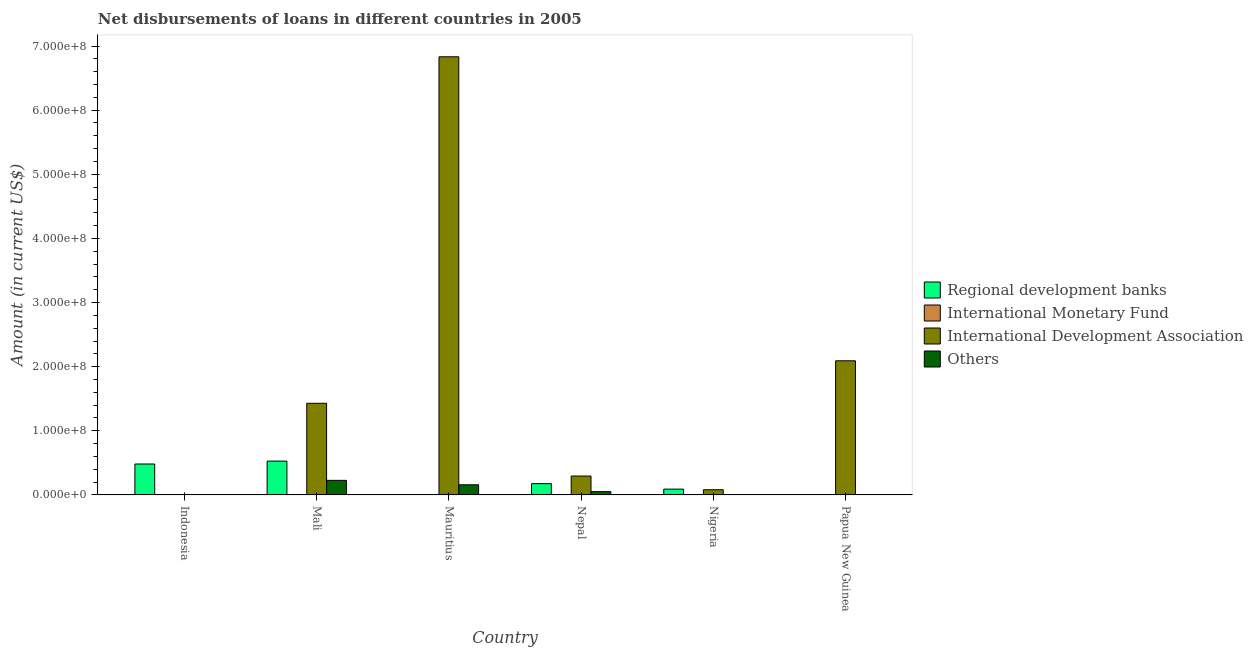What is the label of the 3rd group of bars from the left?
Provide a short and direct response. Mauritius. What is the amount of loan disimbursed by regional development banks in Mauritius?
Your answer should be very brief. 0. Across all countries, what is the maximum amount of loan disimbursed by international development association?
Offer a terse response. 6.83e+08. Across all countries, what is the minimum amount of loan disimbursed by international monetary fund?
Provide a short and direct response. 0. In which country was the amount of loan disimbursed by international development association maximum?
Provide a short and direct response. Mauritius. What is the difference between the amount of loan disimbursed by regional development banks in Indonesia and that in Nigeria?
Offer a terse response. 3.92e+07. What is the difference between the amount of loan disimbursed by other organisations in Mali and the amount of loan disimbursed by international monetary fund in Papua New Guinea?
Your answer should be very brief. 2.27e+07. What is the average amount of loan disimbursed by international development association per country?
Keep it short and to the point. 1.79e+08. What is the difference between the amount of loan disimbursed by other organisations and amount of loan disimbursed by international development association in Mauritius?
Keep it short and to the point. -6.67e+08. What is the ratio of the amount of loan disimbursed by other organisations in Mali to that in Mauritius?
Provide a short and direct response. 1.44. What is the difference between the highest and the second highest amount of loan disimbursed by other organisations?
Your answer should be compact. 6.90e+06. What is the difference between the highest and the lowest amount of loan disimbursed by other organisations?
Your answer should be very brief. 2.27e+07. Are all the bars in the graph horizontal?
Give a very brief answer. No. What is the difference between two consecutive major ticks on the Y-axis?
Give a very brief answer. 1.00e+08. Are the values on the major ticks of Y-axis written in scientific E-notation?
Provide a short and direct response. Yes. Does the graph contain grids?
Give a very brief answer. No. What is the title of the graph?
Provide a succinct answer. Net disbursements of loans in different countries in 2005. What is the label or title of the Y-axis?
Provide a short and direct response. Amount (in current US$). What is the Amount (in current US$) in Regional development banks in Indonesia?
Your answer should be compact. 4.82e+07. What is the Amount (in current US$) of International Development Association in Indonesia?
Your response must be concise. 0. What is the Amount (in current US$) in Regional development banks in Mali?
Make the answer very short. 5.28e+07. What is the Amount (in current US$) of International Monetary Fund in Mali?
Offer a terse response. 0. What is the Amount (in current US$) of International Development Association in Mali?
Offer a very short reply. 1.43e+08. What is the Amount (in current US$) in Others in Mali?
Offer a terse response. 2.27e+07. What is the Amount (in current US$) in Regional development banks in Mauritius?
Give a very brief answer. 0. What is the Amount (in current US$) in International Monetary Fund in Mauritius?
Your answer should be compact. 0. What is the Amount (in current US$) of International Development Association in Mauritius?
Make the answer very short. 6.83e+08. What is the Amount (in current US$) in Others in Mauritius?
Provide a short and direct response. 1.58e+07. What is the Amount (in current US$) in Regional development banks in Nepal?
Keep it short and to the point. 1.76e+07. What is the Amount (in current US$) in International Development Association in Nepal?
Make the answer very short. 2.95e+07. What is the Amount (in current US$) of Others in Nepal?
Make the answer very short. 5.12e+06. What is the Amount (in current US$) in Regional development banks in Nigeria?
Your answer should be compact. 9.06e+06. What is the Amount (in current US$) in International Monetary Fund in Nigeria?
Your response must be concise. 0. What is the Amount (in current US$) in International Development Association in Nigeria?
Provide a succinct answer. 8.09e+06. What is the Amount (in current US$) of Regional development banks in Papua New Guinea?
Your answer should be compact. 0. What is the Amount (in current US$) of International Development Association in Papua New Guinea?
Provide a succinct answer. 2.09e+08. Across all countries, what is the maximum Amount (in current US$) in Regional development banks?
Keep it short and to the point. 5.28e+07. Across all countries, what is the maximum Amount (in current US$) in International Development Association?
Provide a short and direct response. 6.83e+08. Across all countries, what is the maximum Amount (in current US$) in Others?
Offer a very short reply. 2.27e+07. Across all countries, what is the minimum Amount (in current US$) of Regional development banks?
Offer a terse response. 0. Across all countries, what is the minimum Amount (in current US$) in International Development Association?
Your response must be concise. 0. What is the total Amount (in current US$) of Regional development banks in the graph?
Your answer should be very brief. 1.28e+08. What is the total Amount (in current US$) of International Development Association in the graph?
Offer a terse response. 1.07e+09. What is the total Amount (in current US$) of Others in the graph?
Provide a succinct answer. 4.37e+07. What is the difference between the Amount (in current US$) in Regional development banks in Indonesia and that in Mali?
Give a very brief answer. -4.54e+06. What is the difference between the Amount (in current US$) of Regional development banks in Indonesia and that in Nepal?
Offer a very short reply. 3.06e+07. What is the difference between the Amount (in current US$) of Regional development banks in Indonesia and that in Nigeria?
Provide a short and direct response. 3.92e+07. What is the difference between the Amount (in current US$) in International Development Association in Mali and that in Mauritius?
Make the answer very short. -5.40e+08. What is the difference between the Amount (in current US$) in Others in Mali and that in Mauritius?
Offer a very short reply. 6.90e+06. What is the difference between the Amount (in current US$) in Regional development banks in Mali and that in Nepal?
Give a very brief answer. 3.52e+07. What is the difference between the Amount (in current US$) of International Development Association in Mali and that in Nepal?
Your response must be concise. 1.13e+08. What is the difference between the Amount (in current US$) of Others in Mali and that in Nepal?
Keep it short and to the point. 1.76e+07. What is the difference between the Amount (in current US$) in Regional development banks in Mali and that in Nigeria?
Your answer should be very brief. 4.37e+07. What is the difference between the Amount (in current US$) in International Development Association in Mali and that in Nigeria?
Ensure brevity in your answer.  1.35e+08. What is the difference between the Amount (in current US$) of International Development Association in Mali and that in Papua New Guinea?
Your response must be concise. -6.63e+07. What is the difference between the Amount (in current US$) in International Development Association in Mauritius and that in Nepal?
Ensure brevity in your answer.  6.54e+08. What is the difference between the Amount (in current US$) in Others in Mauritius and that in Nepal?
Your response must be concise. 1.07e+07. What is the difference between the Amount (in current US$) in International Development Association in Mauritius and that in Nigeria?
Your response must be concise. 6.75e+08. What is the difference between the Amount (in current US$) of International Development Association in Mauritius and that in Papua New Guinea?
Your response must be concise. 4.74e+08. What is the difference between the Amount (in current US$) in Regional development banks in Nepal and that in Nigeria?
Offer a very short reply. 8.52e+06. What is the difference between the Amount (in current US$) of International Development Association in Nepal and that in Nigeria?
Offer a terse response. 2.14e+07. What is the difference between the Amount (in current US$) of International Development Association in Nepal and that in Papua New Guinea?
Provide a short and direct response. -1.80e+08. What is the difference between the Amount (in current US$) of International Development Association in Nigeria and that in Papua New Guinea?
Offer a very short reply. -2.01e+08. What is the difference between the Amount (in current US$) of Regional development banks in Indonesia and the Amount (in current US$) of International Development Association in Mali?
Ensure brevity in your answer.  -9.47e+07. What is the difference between the Amount (in current US$) of Regional development banks in Indonesia and the Amount (in current US$) of Others in Mali?
Your answer should be very brief. 2.55e+07. What is the difference between the Amount (in current US$) of Regional development banks in Indonesia and the Amount (in current US$) of International Development Association in Mauritius?
Your response must be concise. -6.35e+08. What is the difference between the Amount (in current US$) in Regional development banks in Indonesia and the Amount (in current US$) in Others in Mauritius?
Provide a succinct answer. 3.24e+07. What is the difference between the Amount (in current US$) in Regional development banks in Indonesia and the Amount (in current US$) in International Development Association in Nepal?
Your answer should be compact. 1.88e+07. What is the difference between the Amount (in current US$) of Regional development banks in Indonesia and the Amount (in current US$) of Others in Nepal?
Offer a terse response. 4.31e+07. What is the difference between the Amount (in current US$) in Regional development banks in Indonesia and the Amount (in current US$) in International Development Association in Nigeria?
Your response must be concise. 4.01e+07. What is the difference between the Amount (in current US$) of Regional development banks in Indonesia and the Amount (in current US$) of International Development Association in Papua New Guinea?
Give a very brief answer. -1.61e+08. What is the difference between the Amount (in current US$) in Regional development banks in Mali and the Amount (in current US$) in International Development Association in Mauritius?
Offer a terse response. -6.30e+08. What is the difference between the Amount (in current US$) in Regional development banks in Mali and the Amount (in current US$) in Others in Mauritius?
Your response must be concise. 3.69e+07. What is the difference between the Amount (in current US$) in International Development Association in Mali and the Amount (in current US$) in Others in Mauritius?
Your answer should be compact. 1.27e+08. What is the difference between the Amount (in current US$) of Regional development banks in Mali and the Amount (in current US$) of International Development Association in Nepal?
Give a very brief answer. 2.33e+07. What is the difference between the Amount (in current US$) of Regional development banks in Mali and the Amount (in current US$) of Others in Nepal?
Your answer should be very brief. 4.76e+07. What is the difference between the Amount (in current US$) of International Development Association in Mali and the Amount (in current US$) of Others in Nepal?
Keep it short and to the point. 1.38e+08. What is the difference between the Amount (in current US$) of Regional development banks in Mali and the Amount (in current US$) of International Development Association in Nigeria?
Provide a succinct answer. 4.47e+07. What is the difference between the Amount (in current US$) in Regional development banks in Mali and the Amount (in current US$) in International Development Association in Papua New Guinea?
Provide a succinct answer. -1.56e+08. What is the difference between the Amount (in current US$) in International Development Association in Mauritius and the Amount (in current US$) in Others in Nepal?
Give a very brief answer. 6.78e+08. What is the difference between the Amount (in current US$) of Regional development banks in Nepal and the Amount (in current US$) of International Development Association in Nigeria?
Make the answer very short. 9.50e+06. What is the difference between the Amount (in current US$) in Regional development banks in Nepal and the Amount (in current US$) in International Development Association in Papua New Guinea?
Offer a terse response. -1.92e+08. What is the difference between the Amount (in current US$) of Regional development banks in Nigeria and the Amount (in current US$) of International Development Association in Papua New Guinea?
Provide a succinct answer. -2.00e+08. What is the average Amount (in current US$) of Regional development banks per country?
Provide a short and direct response. 2.13e+07. What is the average Amount (in current US$) of International Monetary Fund per country?
Give a very brief answer. 0. What is the average Amount (in current US$) in International Development Association per country?
Offer a terse response. 1.79e+08. What is the average Amount (in current US$) of Others per country?
Ensure brevity in your answer.  7.28e+06. What is the difference between the Amount (in current US$) of Regional development banks and Amount (in current US$) of International Development Association in Mali?
Provide a short and direct response. -9.01e+07. What is the difference between the Amount (in current US$) of Regional development banks and Amount (in current US$) of Others in Mali?
Keep it short and to the point. 3.00e+07. What is the difference between the Amount (in current US$) in International Development Association and Amount (in current US$) in Others in Mali?
Your response must be concise. 1.20e+08. What is the difference between the Amount (in current US$) in International Development Association and Amount (in current US$) in Others in Mauritius?
Give a very brief answer. 6.67e+08. What is the difference between the Amount (in current US$) of Regional development banks and Amount (in current US$) of International Development Association in Nepal?
Your answer should be compact. -1.19e+07. What is the difference between the Amount (in current US$) in Regional development banks and Amount (in current US$) in Others in Nepal?
Your answer should be very brief. 1.25e+07. What is the difference between the Amount (in current US$) in International Development Association and Amount (in current US$) in Others in Nepal?
Provide a short and direct response. 2.43e+07. What is the difference between the Amount (in current US$) of Regional development banks and Amount (in current US$) of International Development Association in Nigeria?
Provide a succinct answer. 9.73e+05. What is the ratio of the Amount (in current US$) of Regional development banks in Indonesia to that in Mali?
Offer a terse response. 0.91. What is the ratio of the Amount (in current US$) of Regional development banks in Indonesia to that in Nepal?
Give a very brief answer. 2.74. What is the ratio of the Amount (in current US$) in Regional development banks in Indonesia to that in Nigeria?
Your answer should be compact. 5.32. What is the ratio of the Amount (in current US$) of International Development Association in Mali to that in Mauritius?
Provide a short and direct response. 0.21. What is the ratio of the Amount (in current US$) of Others in Mali to that in Mauritius?
Your answer should be very brief. 1.44. What is the ratio of the Amount (in current US$) of Regional development banks in Mali to that in Nepal?
Make the answer very short. 3. What is the ratio of the Amount (in current US$) of International Development Association in Mali to that in Nepal?
Offer a very short reply. 4.85. What is the ratio of the Amount (in current US$) of Others in Mali to that in Nepal?
Your answer should be compact. 4.43. What is the ratio of the Amount (in current US$) of Regional development banks in Mali to that in Nigeria?
Ensure brevity in your answer.  5.82. What is the ratio of the Amount (in current US$) in International Development Association in Mali to that in Nigeria?
Keep it short and to the point. 17.66. What is the ratio of the Amount (in current US$) of International Development Association in Mali to that in Papua New Guinea?
Your answer should be very brief. 0.68. What is the ratio of the Amount (in current US$) of International Development Association in Mauritius to that in Nepal?
Make the answer very short. 23.2. What is the ratio of the Amount (in current US$) in Others in Mauritius to that in Nepal?
Make the answer very short. 3.09. What is the ratio of the Amount (in current US$) in International Development Association in Mauritius to that in Nigeria?
Your answer should be very brief. 84.44. What is the ratio of the Amount (in current US$) in International Development Association in Mauritius to that in Papua New Guinea?
Your answer should be compact. 3.27. What is the ratio of the Amount (in current US$) in Regional development banks in Nepal to that in Nigeria?
Your answer should be very brief. 1.94. What is the ratio of the Amount (in current US$) of International Development Association in Nepal to that in Nigeria?
Your answer should be compact. 3.64. What is the ratio of the Amount (in current US$) of International Development Association in Nepal to that in Papua New Guinea?
Give a very brief answer. 0.14. What is the ratio of the Amount (in current US$) in International Development Association in Nigeria to that in Papua New Guinea?
Make the answer very short. 0.04. What is the difference between the highest and the second highest Amount (in current US$) in Regional development banks?
Ensure brevity in your answer.  4.54e+06. What is the difference between the highest and the second highest Amount (in current US$) of International Development Association?
Keep it short and to the point. 4.74e+08. What is the difference between the highest and the second highest Amount (in current US$) in Others?
Ensure brevity in your answer.  6.90e+06. What is the difference between the highest and the lowest Amount (in current US$) of Regional development banks?
Give a very brief answer. 5.28e+07. What is the difference between the highest and the lowest Amount (in current US$) of International Development Association?
Your response must be concise. 6.83e+08. What is the difference between the highest and the lowest Amount (in current US$) in Others?
Make the answer very short. 2.27e+07. 